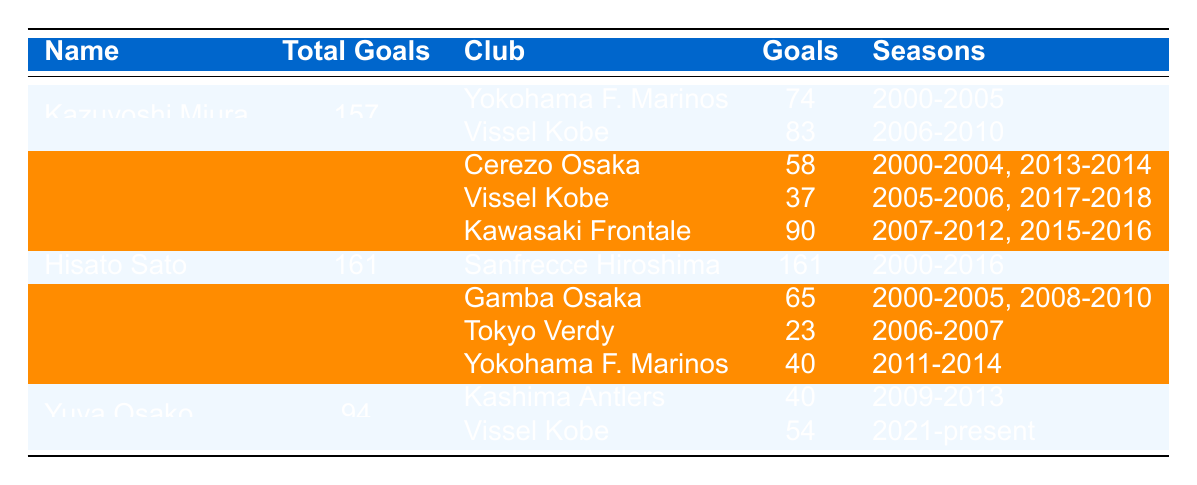What is the total number of goals scored by Yoshito Okubo? The total goals scored by Yoshito Okubo is directly listed in the table under the "Total Goals" column, which shows 185.
Answer: 185 Which player scored the most goals for a single club? According to the table, Hisato Sato scored all 161 of his goals for Sanfrecce Hiroshima, indicating he had the highest single-club tally.
Answer: Hisato Sato How many goals did Kazuyoshi Miura score while playing for Vissel Kobe? The table indicates that Kazuyoshi Miura scored 83 goals while playing for Vissel Kobe, which is noted in the "Goals" column next to the club name.
Answer: 83 Is it true that Yuya Osako played for Yokohama F. Marinos? Referring to the table, Yuya Osako's club history does not include Yokohama F. Marinos, as he only played for Kashima Antlers and Vissel Kobe.
Answer: No How many total clubs did Masashi Oguro play for in the J1 League? The table lists three clubs under Masashi Oguro: Gamba Osaka, Tokyo Verdy, and Yokohama F. Marinos, indicating he played for a total of three clubs.
Answer: 3 What is the cumulative number of goals scored by all players listed in the table? Adding the total goals: 157 (Miura) + 185 (Okubo) + 161 (Sato) + 128 (Oguro) + 94 (Osako) = 725.
Answer: 725 Which player had the highest goal tally in the years 2000 to 2010? Looking at the total goals in the "Total Goals" column, Yoshito Okubo has the highest tally during those years, measuring in at 185, confirming he tops the list.
Answer: Yoshito Okubo What was the difference in total goals between Hisato Sato and Masashi Oguro? Hisato Sato scored 161 goals, while Masashi Oguro scored 128 goals; the difference is 161 - 128 = 33.
Answer: 33 Which club did Kazuyoshi Miura score more goals for, in terms of individual goal output? Miura scored 74 goals for Yokohama F. Marinos and 83 goals for Vissel Kobe; thus he scored more goals for Vissel Kobe.
Answer: Vissel Kobe How many goals did Yoshito Okubo score for Kawasaki Frontale? The table specifies that Yoshito Okubo scored 90 goals for Kawasaki Frontale, which is directly represented under the respective club.
Answer: 90 